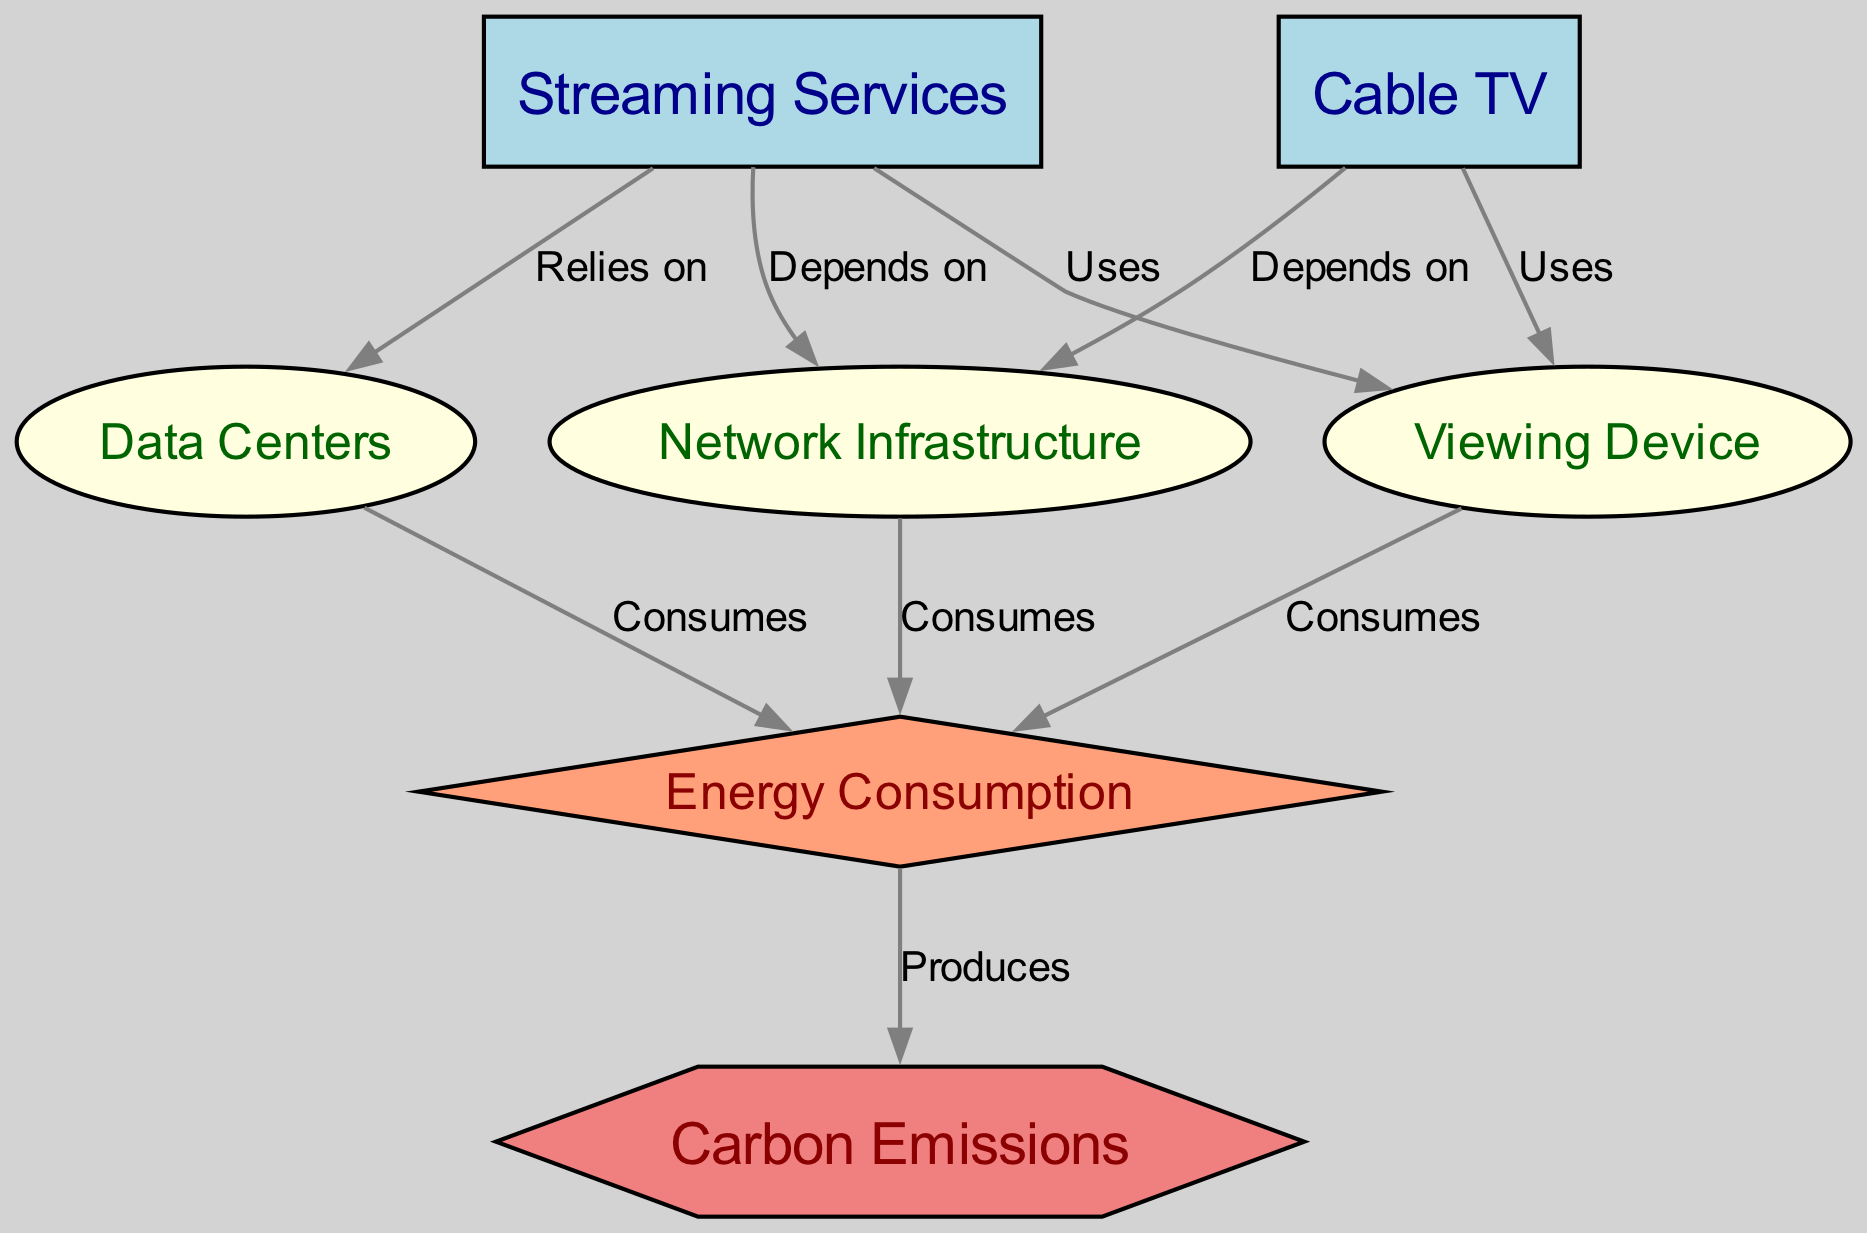What are the two main types of viewing options represented in the diagram? The diagram shows two main types of viewing options: "Streaming Services" and "Cable TV." These are the two primary nodes for viewing options in the diagram.
Answer: Streaming Services, Cable TV How many nodes are present in total? By counting all the distinct nodes listed in the diagram, there are a total of 7 nodes: Streaming Services, Cable TV, Viewing Device, Data Centers, Network Infrastructure, Energy Consumption, and Carbon Emissions.
Answer: 7 Which node produces carbon emissions? The diagram indicates that "Energy Consumption" is the node that produces carbon emissions, as it is connected to the "Carbon Emissions" node with a "Produces" relationship.
Answer: Energy Consumption What type of node is "Energy Consumption"? In the diagram, "Energy Consumption" is represented as a diamond-shaped node, which indicates its unique role in the flow of energy and its relation to carbon emissions.
Answer: Diamond How does streaming services relate to data centers? The diagram shows that "Streaming Services" relies on "Data Centers," indicating a direct relationship in which streaming services depend on data centers for their functionality.
Answer: Relies on Which viewing option consumes energy through a device? Both "Streaming Services" and "Cable TV" are linked to "Viewing Device," indicating that both options consume energy through the device used to watch.
Answer: Both options Which infrastructure is crucial for both streaming and cable TV? The diagram illustrates that both "Streaming Services" and "Cable TV" depend on "Network Infrastructure," making it a critical element for both viewing options.
Answer: Network Infrastructure What is the final product of energy consumption in the diagram? The diagram shows that the process of energy consumption ultimately produces "Carbon Emissions," which is the final output resulting from energy usage for both viewing options.
Answer: Carbon Emissions How does the viewing device interact with energy consumption? The diagram depicts that "Viewing Device" consumes energy, indicating that the devices used for viewing television contribute to the overall energy consumption in the process.
Answer: Consumes 